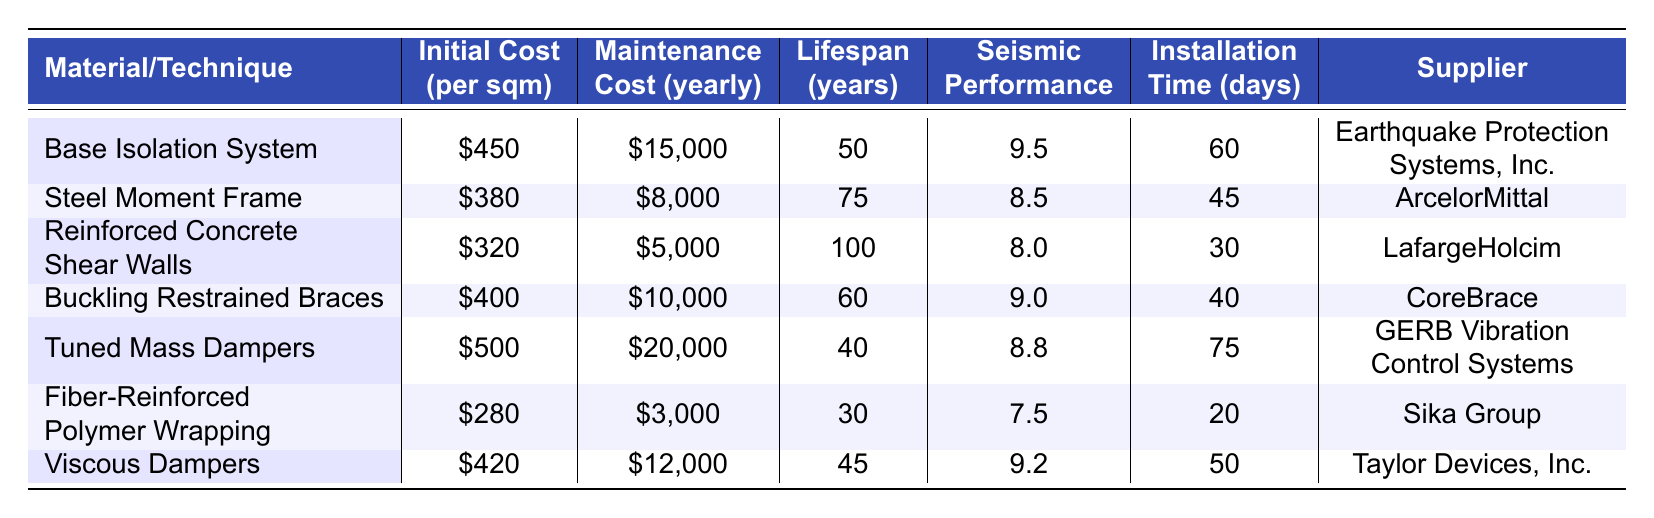What is the initial cost per square meter for the Buckling Restrained Braces technique? The table lists the initial cost per square meter for Buckling Restrained Braces as $400.
Answer: $400 Which construction material has the longest lifespan? The table indicates that Reinforced Concrete Shear Walls have the longest lifespan at 100 years.
Answer: 100 years How much does maintenance cost per year for the Steel Moment Frame technique? According to the table, the maintenance cost per year for the Steel Moment Frame is $8,000.
Answer: $8,000 What is the total lifespan of the Fiber-Reinforced Polymer Wrapping and the Tuned Mass Dampers combined? The lifespan of Fiber-Reinforced Polymer Wrapping is 30 years and that of Tuned Mass Dampers is 40 years, so combined they total 30 + 40 = 70 years.
Answer: 70 years Does the Base Isolation System have a higher Seismic Performance Rating than the Tuned Mass Dampers? The Seismic Performance Rating for Base Isolation System is 9.5, while for Tuned Mass Dampers it is 8.8, thus Base Isolation System has a higher rating.
Answer: Yes What is the difference in installation time between the Steel Moment Frame and the Reinforced Concrete Shear Walls? The installation time for the Steel Moment Frame is 45 days, and for Reinforced Concrete Shear Walls, it is 30 days, hence the difference is 45 - 30 = 15 days.
Answer: 15 days Which material has the highest maintenance cost per year, and what is that cost? The material with the highest maintenance cost is Tuned Mass Dampers at $20,000 per year as per the table.
Answer: Tuned Mass Dampers, $20,000 If you sum up the initial costs of all the construction materials, what total do you get? The initial costs are $450 + $380 + $320 + $400 + $500 + $280 + $420 = $2,750.
Answer: $2,750 How many construction technologies have a Seismic Performance Rating above 9? According to the table, there are three techniques with a Seismic Performance Rating above 9: Base Isolation System (9.5), Buckling Restrained Braces (9.0), and Viscous Dampers (9.2).
Answer: 3 Is there any construction technique that has a lifespan of more than 75 years? Yes, the Reinforced Concrete Shear Walls have a lifespan of 100 years, which is more than 75 years.
Answer: Yes What is the average initial cost per square meter of all materials listed? To find the average, sum the initial costs ($450 + $380 + $320 + $400 + $500 + $280 + $420 = $2,750) and divide by the number of materials (7), resulting in an average of $2,750/7 ≈ $392.86.
Answer: $392.86 